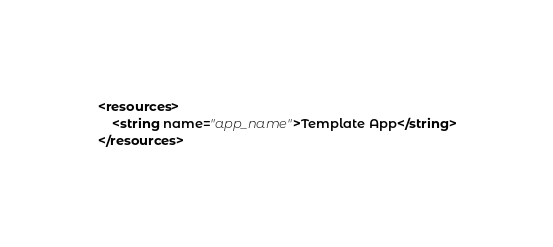<code> <loc_0><loc_0><loc_500><loc_500><_XML_><resources>
    <string name="app_name">Template App</string>
</resources>
</code> 